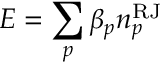Convert formula to latex. <formula><loc_0><loc_0><loc_500><loc_500>E = \sum _ { p } \beta _ { p } n _ { p } ^ { R J }</formula> 